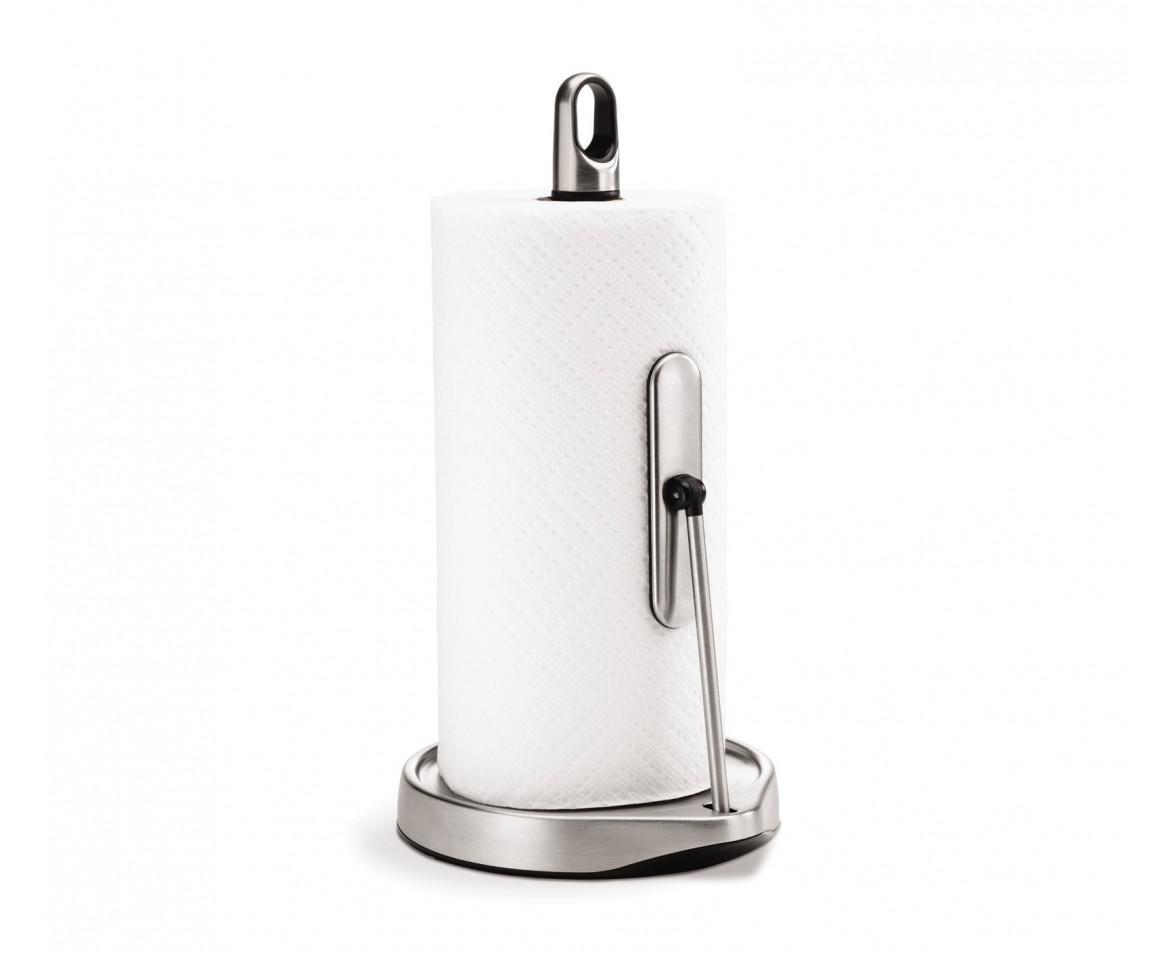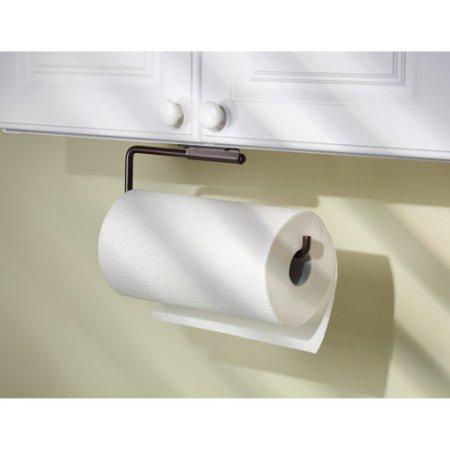The first image is the image on the left, the second image is the image on the right. For the images displayed, is the sentence "There is at least one paper towel roll hanging" factually correct? Answer yes or no. Yes. The first image is the image on the left, the second image is the image on the right. For the images displayed, is the sentence "A roll of paper towels is on a rack under a cabinet with the next towel hanging from the back." factually correct? Answer yes or no. Yes. 